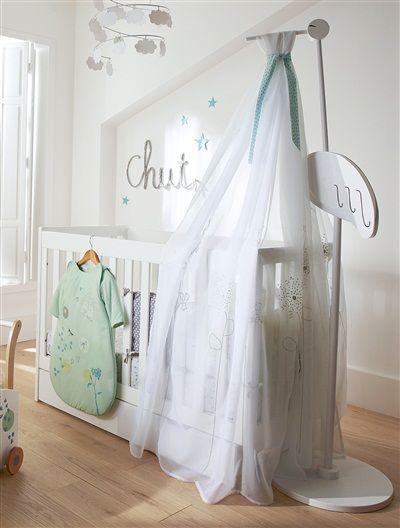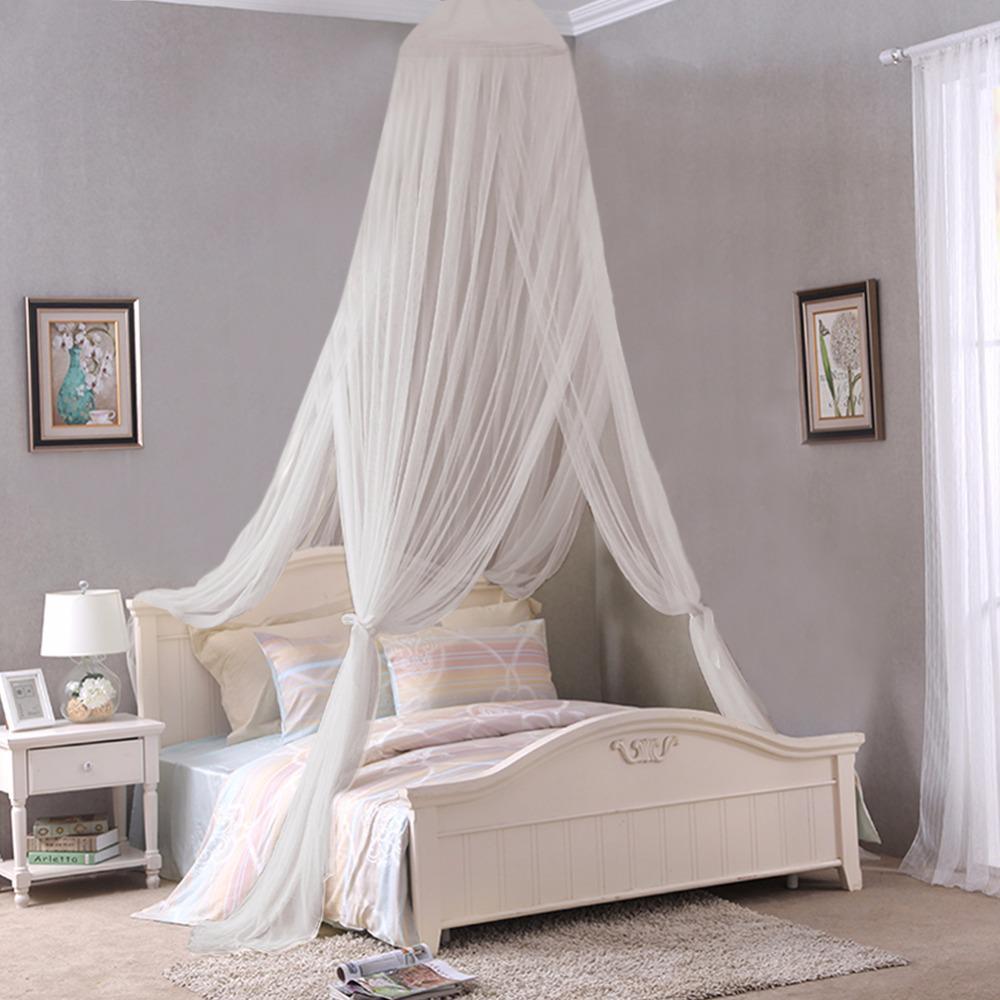The first image is the image on the left, the second image is the image on the right. Assess this claim about the two images: "There is exactly one crib with netting above it.". Correct or not? Answer yes or no. Yes. 